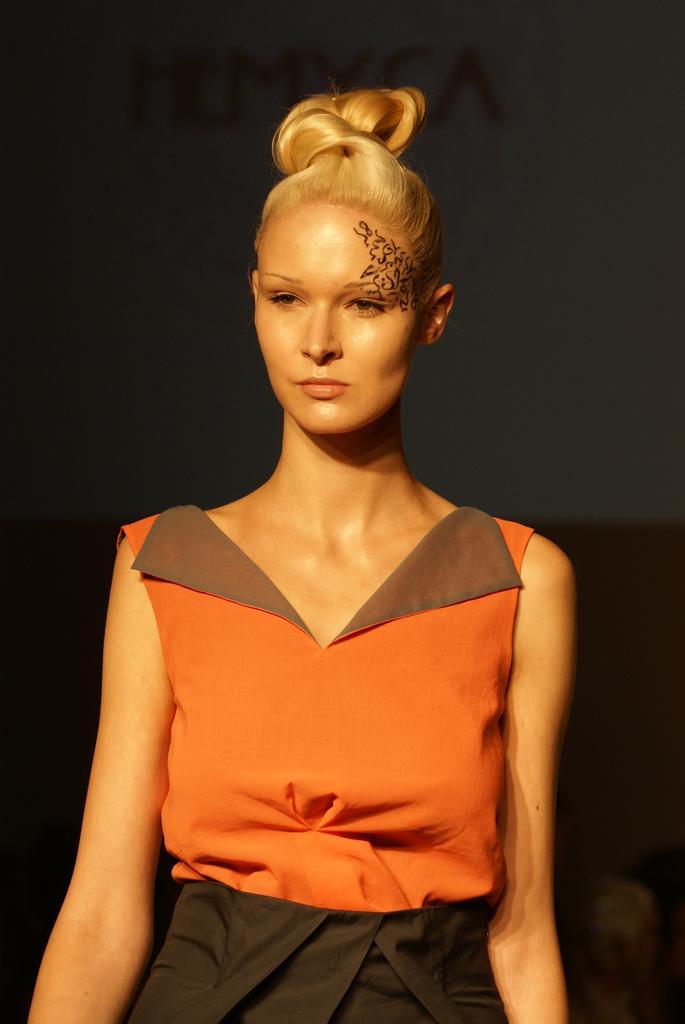Could you give a brief overview of what you see in this image? In this picture there is a woman and we can see tattoo on her face. In the background of the image it is blurry. 